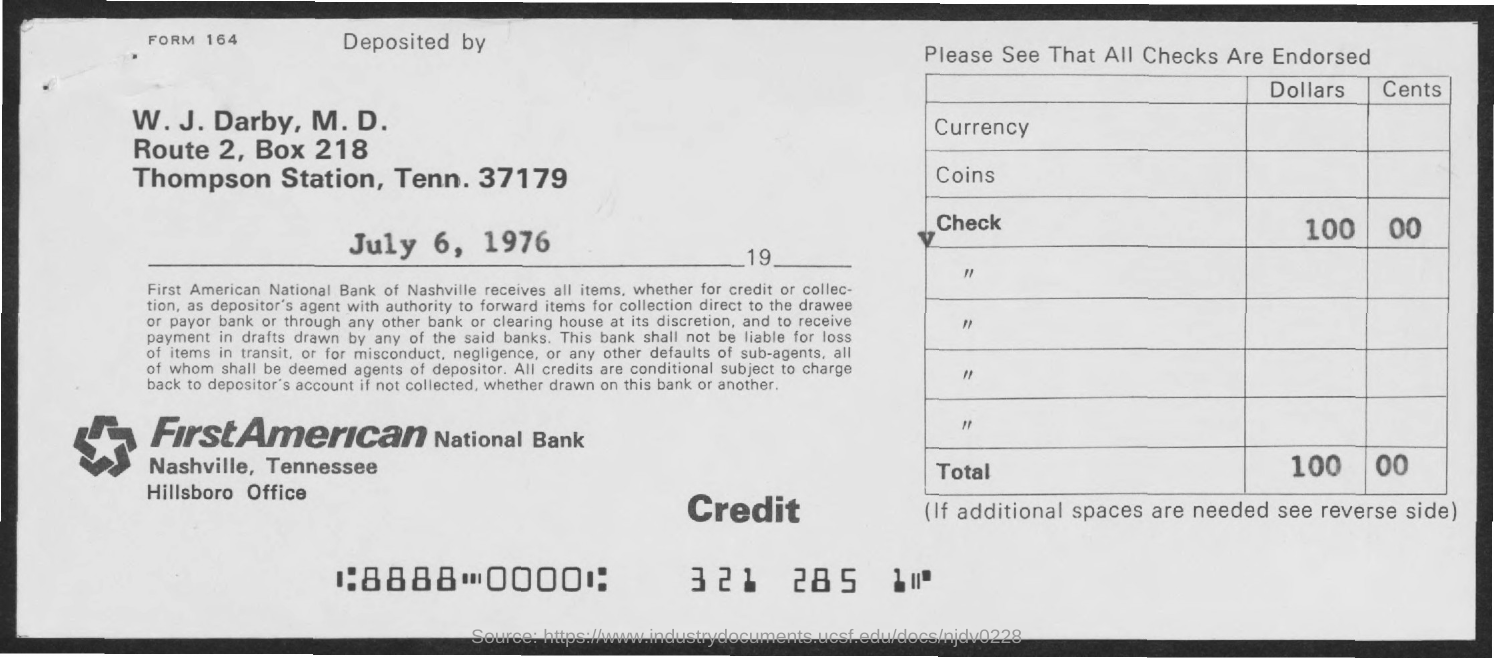Who has deposited the check amount?
Make the answer very short. W. J. Darby, M. D. What is the deposit date mentioned in the form?
Make the answer very short. July 6, 1976. 